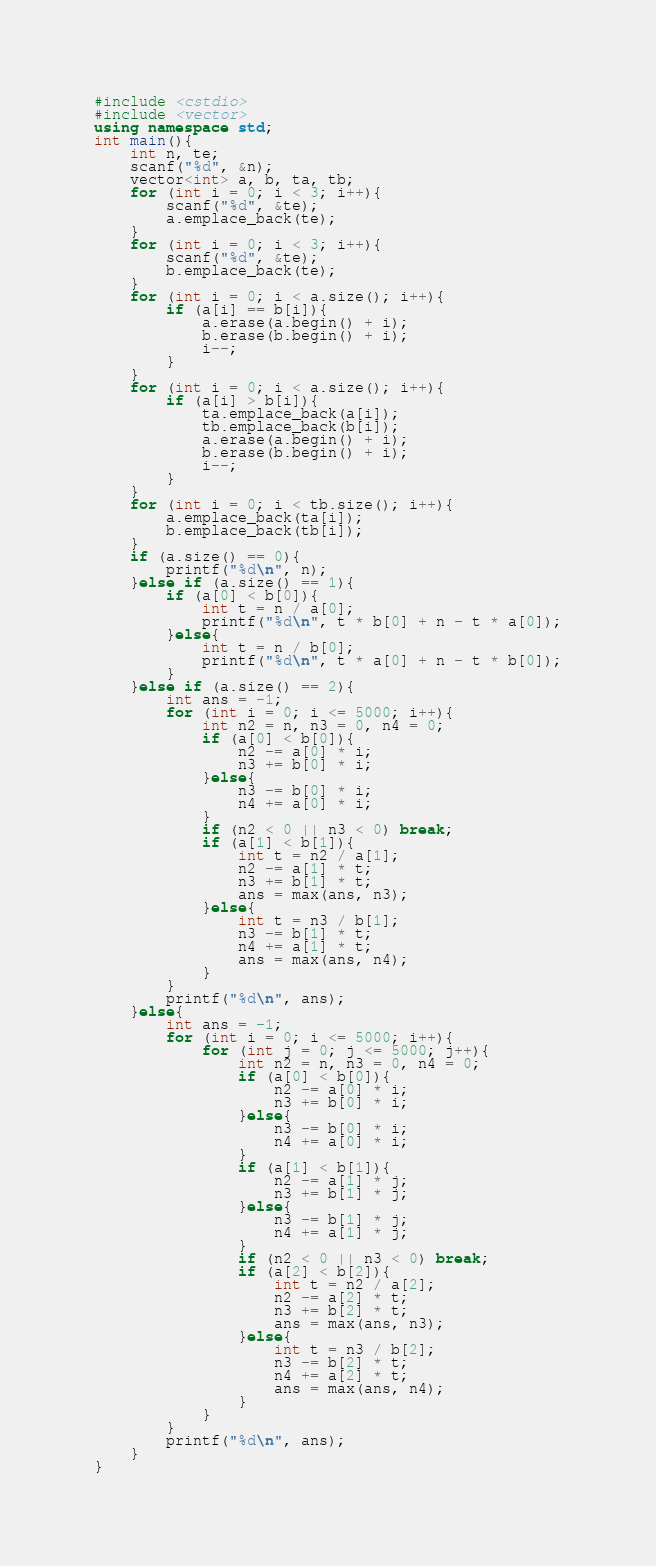Convert code to text. <code><loc_0><loc_0><loc_500><loc_500><_C++_>#include <cstdio>
#include <vector>
using namespace std;
int main(){
	int n, te;
	scanf("%d", &n);
	vector<int> a, b, ta, tb;
	for (int i = 0; i < 3; i++){
		scanf("%d", &te);
		a.emplace_back(te);
	}
	for (int i = 0; i < 3; i++){
		scanf("%d", &te);
		b.emplace_back(te);
	}
	for (int i = 0; i < a.size(); i++){
		if (a[i] == b[i]){
			a.erase(a.begin() + i);
			b.erase(b.begin() + i);
			i--;
		}
	}
	for (int i = 0; i < a.size(); i++){
		if (a[i] > b[i]){
			ta.emplace_back(a[i]);
			tb.emplace_back(b[i]);
			a.erase(a.begin() + i);
			b.erase(b.begin() + i);
			i--;
		}
	}
	for (int i = 0; i < tb.size(); i++){
		a.emplace_back(ta[i]);
		b.emplace_back(tb[i]);
	}
	if (a.size() == 0){
		printf("%d\n", n);
	}else if (a.size() == 1){
		if (a[0] < b[0]){
			int t = n / a[0];
			printf("%d\n", t * b[0] + n - t * a[0]);
		}else{
			int t = n / b[0];
			printf("%d\n", t * a[0] + n - t * b[0]);
		}
	}else if (a.size() == 2){
		int ans = -1;
		for (int i = 0; i <= 5000; i++){
			int n2 = n, n3 = 0, n4 = 0;
			if (a[0] < b[0]){
				n2 -= a[0] * i;
				n3 += b[0] * i;
			}else{
				n3 -= b[0] * i;
				n4 += a[0] * i;
			}
			if (n2 < 0 || n3 < 0) break;
			if (a[1] < b[1]){
				int t = n2 / a[1];
				n2 -= a[1] * t;
				n3 += b[1] * t;
				ans = max(ans, n3);
			}else{
				int t = n3 / b[1];
				n3 -= b[1] * t;
				n4 += a[1] * t;
				ans = max(ans, n4);
			}
		}
		printf("%d\n", ans);
	}else{
		int ans = -1;
		for (int i = 0; i <= 5000; i++){
			for (int j = 0; j <= 5000; j++){
				int n2 = n, n3 = 0, n4 = 0;
				if (a[0] < b[0]){
					n2 -= a[0] * i;
					n3 += b[0] * i;
				}else{
					n3 -= b[0] * i;
					n4 += a[0] * i;
				}
				if (a[1] < b[1]){
					n2 -= a[1] * j;
					n3 += b[1] * j;
				}else{
					n3 -= b[1] * j;
					n4 += a[1] * j;
				}
				if (n2 < 0 || n3 < 0) break;
				if (a[2] < b[2]){
					int t = n2 / a[2];
					n2 -= a[2] * t;
					n3 += b[2] * t;
					ans = max(ans, n3);
				}else{
					int t = n3 / b[2];
					n3 -= b[2] * t;
					n4 += a[2] * t;
					ans = max(ans, n4);
				}
			}
		}
		printf("%d\n", ans);
	}
}</code> 